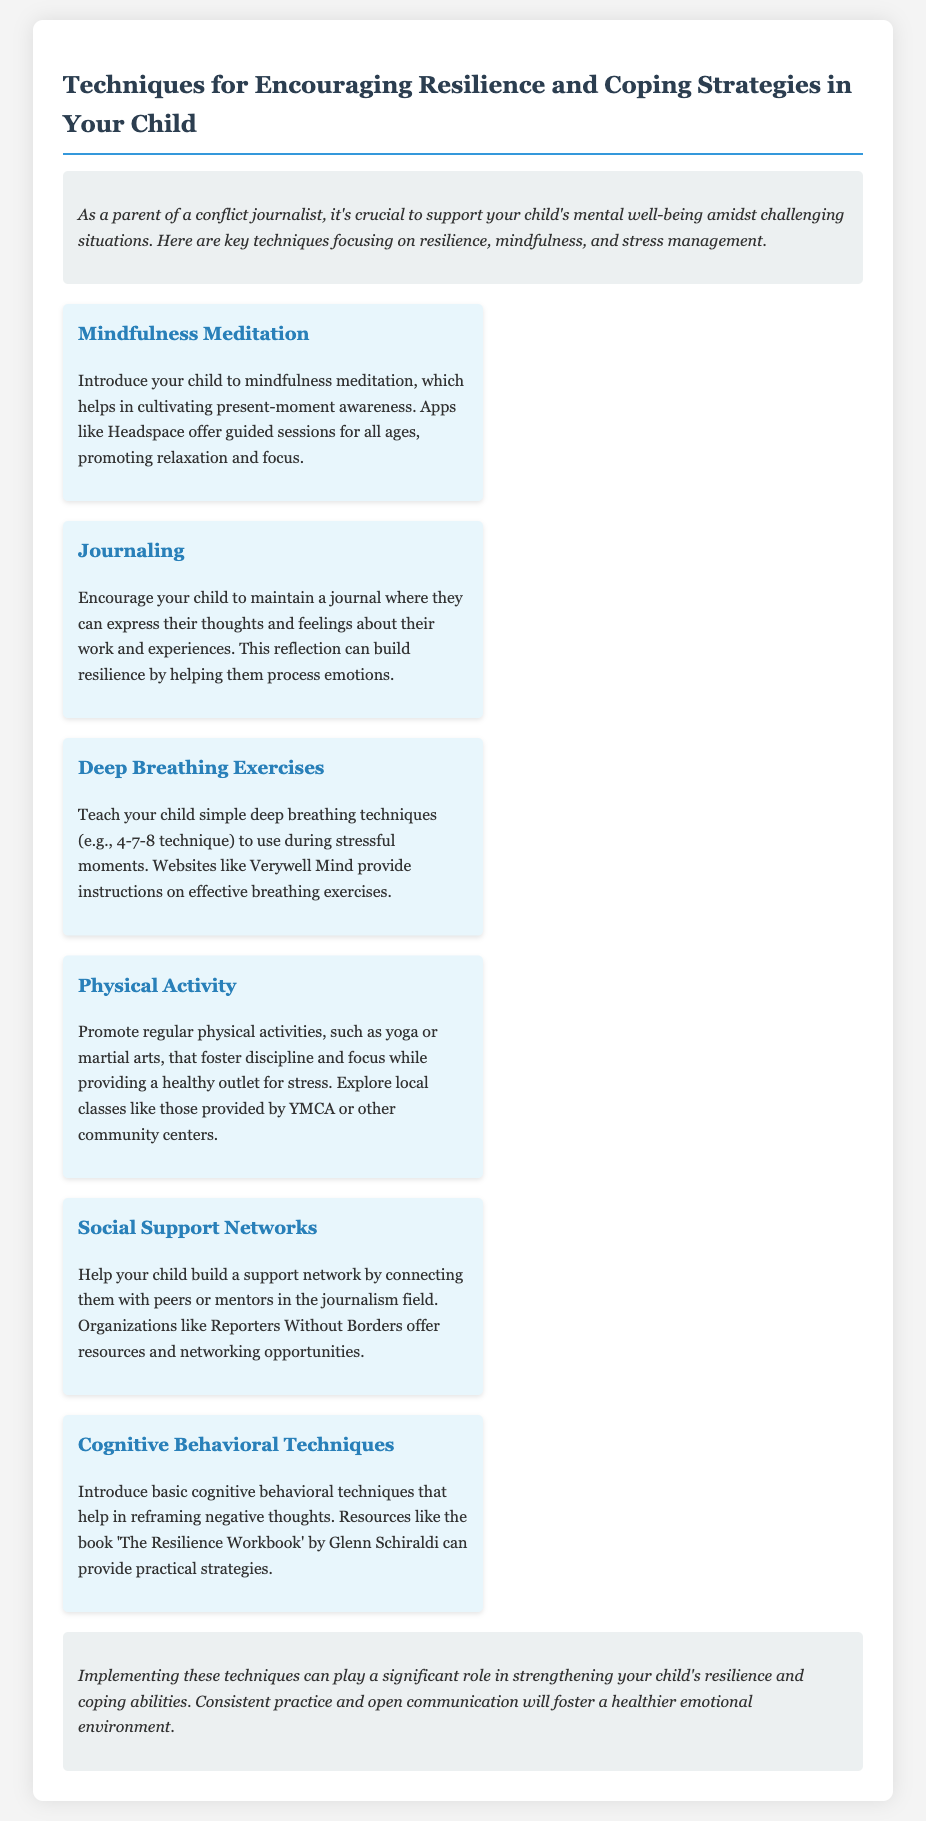What is the title of the memo? The title is explicitly stated at the beginning of the document, indicating the main topic.
Answer: Techniques for Encouraging Resilience and Coping Strategies in Your Child What is one platform mentioned for mindfulness meditation? The document lists an app that provides guided mindfulness sessions for children.
Answer: Headspace What exercise technique is taught to use during stressful moments? The memo explains a breathing technique that can help during moments of stress or anxiety.
Answer: Deep Breathing Exercises Which activity is suggested for fostering discipline and focus? The document mentions a type of physical activity beneficial for stress relief and mental focus.
Answer: Yoga What is the purpose of journaling according to the memo? The document describes journaling as a way for children to express their thoughts and emotions regarding their work.
Answer: Express thoughts and feelings What role do social support networks play? The memo explains that building social connections can help provide emotional and professional support.
Answer: Emotional and professional support 